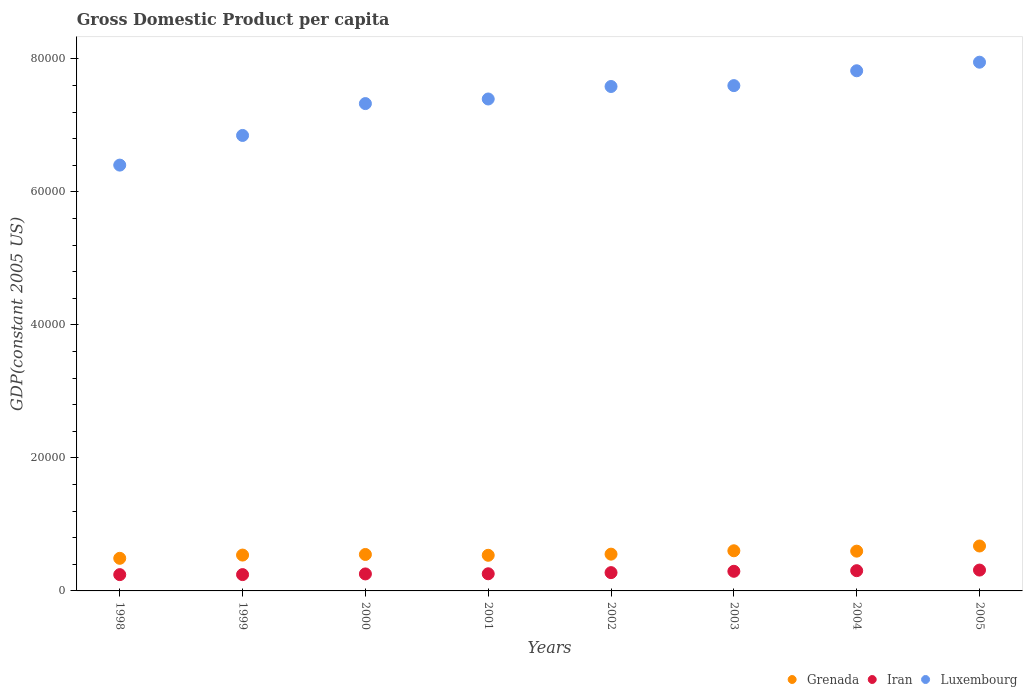Is the number of dotlines equal to the number of legend labels?
Your response must be concise. Yes. What is the GDP per capita in Iran in 2002?
Your response must be concise. 2749.31. Across all years, what is the maximum GDP per capita in Iran?
Offer a very short reply. 3135.19. Across all years, what is the minimum GDP per capita in Luxembourg?
Ensure brevity in your answer.  6.40e+04. In which year was the GDP per capita in Luxembourg maximum?
Offer a very short reply. 2005. What is the total GDP per capita in Luxembourg in the graph?
Keep it short and to the point. 5.89e+05. What is the difference between the GDP per capita in Iran in 2000 and that in 2005?
Offer a terse response. -581.15. What is the difference between the GDP per capita in Grenada in 1998 and the GDP per capita in Iran in 2000?
Make the answer very short. 2349.24. What is the average GDP per capita in Grenada per year?
Give a very brief answer. 5678.86. In the year 2004, what is the difference between the GDP per capita in Luxembourg and GDP per capita in Iran?
Offer a terse response. 7.52e+04. What is the ratio of the GDP per capita in Grenada in 1999 to that in 2003?
Make the answer very short. 0.89. Is the difference between the GDP per capita in Luxembourg in 1999 and 2003 greater than the difference between the GDP per capita in Iran in 1999 and 2003?
Provide a succinct answer. No. What is the difference between the highest and the second highest GDP per capita in Luxembourg?
Offer a very short reply. 1289.74. What is the difference between the highest and the lowest GDP per capita in Grenada?
Provide a succinct answer. 1851.11. In how many years, is the GDP per capita in Grenada greater than the average GDP per capita in Grenada taken over all years?
Provide a succinct answer. 3. Is it the case that in every year, the sum of the GDP per capita in Luxembourg and GDP per capita in Grenada  is greater than the GDP per capita in Iran?
Provide a short and direct response. Yes. Does the GDP per capita in Grenada monotonically increase over the years?
Your answer should be very brief. No. Is the GDP per capita in Grenada strictly less than the GDP per capita in Luxembourg over the years?
Your answer should be very brief. Yes. How many dotlines are there?
Give a very brief answer. 3. How many years are there in the graph?
Your answer should be compact. 8. Does the graph contain any zero values?
Give a very brief answer. No. Does the graph contain grids?
Offer a very short reply. No. How many legend labels are there?
Offer a terse response. 3. What is the title of the graph?
Offer a terse response. Gross Domestic Product per capita. Does "Cyprus" appear as one of the legend labels in the graph?
Keep it short and to the point. No. What is the label or title of the X-axis?
Offer a very short reply. Years. What is the label or title of the Y-axis?
Your response must be concise. GDP(constant 2005 US). What is the GDP(constant 2005 US) in Grenada in 1998?
Offer a terse response. 4903.28. What is the GDP(constant 2005 US) in Iran in 1998?
Your answer should be compact. 2448.68. What is the GDP(constant 2005 US) of Luxembourg in 1998?
Ensure brevity in your answer.  6.40e+04. What is the GDP(constant 2005 US) in Grenada in 1999?
Provide a short and direct response. 5389.76. What is the GDP(constant 2005 US) of Iran in 1999?
Give a very brief answer. 2452.83. What is the GDP(constant 2005 US) in Luxembourg in 1999?
Keep it short and to the point. 6.85e+04. What is the GDP(constant 2005 US) of Grenada in 2000?
Ensure brevity in your answer.  5481.04. What is the GDP(constant 2005 US) of Iran in 2000?
Ensure brevity in your answer.  2554.04. What is the GDP(constant 2005 US) of Luxembourg in 2000?
Keep it short and to the point. 7.33e+04. What is the GDP(constant 2005 US) of Grenada in 2001?
Provide a short and direct response. 5358.03. What is the GDP(constant 2005 US) of Iran in 2001?
Provide a short and direct response. 2577.45. What is the GDP(constant 2005 US) in Luxembourg in 2001?
Your answer should be very brief. 7.40e+04. What is the GDP(constant 2005 US) in Grenada in 2002?
Give a very brief answer. 5528.58. What is the GDP(constant 2005 US) of Iran in 2002?
Ensure brevity in your answer.  2749.31. What is the GDP(constant 2005 US) in Luxembourg in 2002?
Your answer should be compact. 7.58e+04. What is the GDP(constant 2005 US) in Grenada in 2003?
Your answer should be compact. 6035.78. What is the GDP(constant 2005 US) of Iran in 2003?
Make the answer very short. 2950.85. What is the GDP(constant 2005 US) in Luxembourg in 2003?
Your answer should be very brief. 7.60e+04. What is the GDP(constant 2005 US) of Grenada in 2004?
Offer a very short reply. 5980. What is the GDP(constant 2005 US) of Iran in 2004?
Your response must be concise. 3043.29. What is the GDP(constant 2005 US) in Luxembourg in 2004?
Ensure brevity in your answer.  7.82e+04. What is the GDP(constant 2005 US) of Grenada in 2005?
Provide a short and direct response. 6754.38. What is the GDP(constant 2005 US) in Iran in 2005?
Ensure brevity in your answer.  3135.19. What is the GDP(constant 2005 US) of Luxembourg in 2005?
Ensure brevity in your answer.  7.95e+04. Across all years, what is the maximum GDP(constant 2005 US) in Grenada?
Your response must be concise. 6754.38. Across all years, what is the maximum GDP(constant 2005 US) in Iran?
Your answer should be very brief. 3135.19. Across all years, what is the maximum GDP(constant 2005 US) in Luxembourg?
Provide a short and direct response. 7.95e+04. Across all years, what is the minimum GDP(constant 2005 US) in Grenada?
Ensure brevity in your answer.  4903.28. Across all years, what is the minimum GDP(constant 2005 US) in Iran?
Your response must be concise. 2448.68. Across all years, what is the minimum GDP(constant 2005 US) of Luxembourg?
Keep it short and to the point. 6.40e+04. What is the total GDP(constant 2005 US) of Grenada in the graph?
Offer a very short reply. 4.54e+04. What is the total GDP(constant 2005 US) in Iran in the graph?
Give a very brief answer. 2.19e+04. What is the total GDP(constant 2005 US) in Luxembourg in the graph?
Ensure brevity in your answer.  5.89e+05. What is the difference between the GDP(constant 2005 US) in Grenada in 1998 and that in 1999?
Offer a very short reply. -486.49. What is the difference between the GDP(constant 2005 US) in Iran in 1998 and that in 1999?
Provide a short and direct response. -4.15. What is the difference between the GDP(constant 2005 US) in Luxembourg in 1998 and that in 1999?
Your answer should be very brief. -4459.64. What is the difference between the GDP(constant 2005 US) in Grenada in 1998 and that in 2000?
Ensure brevity in your answer.  -577.76. What is the difference between the GDP(constant 2005 US) of Iran in 1998 and that in 2000?
Give a very brief answer. -105.35. What is the difference between the GDP(constant 2005 US) in Luxembourg in 1998 and that in 2000?
Your response must be concise. -9249.24. What is the difference between the GDP(constant 2005 US) in Grenada in 1998 and that in 2001?
Give a very brief answer. -454.76. What is the difference between the GDP(constant 2005 US) in Iran in 1998 and that in 2001?
Your response must be concise. -128.77. What is the difference between the GDP(constant 2005 US) in Luxembourg in 1998 and that in 2001?
Keep it short and to the point. -9940.9. What is the difference between the GDP(constant 2005 US) of Grenada in 1998 and that in 2002?
Give a very brief answer. -625.3. What is the difference between the GDP(constant 2005 US) of Iran in 1998 and that in 2002?
Provide a short and direct response. -300.63. What is the difference between the GDP(constant 2005 US) in Luxembourg in 1998 and that in 2002?
Keep it short and to the point. -1.18e+04. What is the difference between the GDP(constant 2005 US) of Grenada in 1998 and that in 2003?
Your answer should be compact. -1132.51. What is the difference between the GDP(constant 2005 US) in Iran in 1998 and that in 2003?
Ensure brevity in your answer.  -502.17. What is the difference between the GDP(constant 2005 US) of Luxembourg in 1998 and that in 2003?
Offer a terse response. -1.20e+04. What is the difference between the GDP(constant 2005 US) in Grenada in 1998 and that in 2004?
Keep it short and to the point. -1076.72. What is the difference between the GDP(constant 2005 US) of Iran in 1998 and that in 2004?
Provide a short and direct response. -594.61. What is the difference between the GDP(constant 2005 US) in Luxembourg in 1998 and that in 2004?
Offer a very short reply. -1.42e+04. What is the difference between the GDP(constant 2005 US) of Grenada in 1998 and that in 2005?
Your answer should be compact. -1851.11. What is the difference between the GDP(constant 2005 US) in Iran in 1998 and that in 2005?
Provide a succinct answer. -686.51. What is the difference between the GDP(constant 2005 US) of Luxembourg in 1998 and that in 2005?
Provide a succinct answer. -1.55e+04. What is the difference between the GDP(constant 2005 US) of Grenada in 1999 and that in 2000?
Offer a very short reply. -91.27. What is the difference between the GDP(constant 2005 US) of Iran in 1999 and that in 2000?
Your answer should be very brief. -101.21. What is the difference between the GDP(constant 2005 US) of Luxembourg in 1999 and that in 2000?
Make the answer very short. -4789.6. What is the difference between the GDP(constant 2005 US) of Grenada in 1999 and that in 2001?
Give a very brief answer. 31.73. What is the difference between the GDP(constant 2005 US) in Iran in 1999 and that in 2001?
Give a very brief answer. -124.62. What is the difference between the GDP(constant 2005 US) in Luxembourg in 1999 and that in 2001?
Offer a terse response. -5481.26. What is the difference between the GDP(constant 2005 US) of Grenada in 1999 and that in 2002?
Give a very brief answer. -138.82. What is the difference between the GDP(constant 2005 US) in Iran in 1999 and that in 2002?
Provide a short and direct response. -296.48. What is the difference between the GDP(constant 2005 US) in Luxembourg in 1999 and that in 2002?
Keep it short and to the point. -7360.54. What is the difference between the GDP(constant 2005 US) in Grenada in 1999 and that in 2003?
Give a very brief answer. -646.02. What is the difference between the GDP(constant 2005 US) of Iran in 1999 and that in 2003?
Your answer should be very brief. -498.02. What is the difference between the GDP(constant 2005 US) of Luxembourg in 1999 and that in 2003?
Keep it short and to the point. -7491.68. What is the difference between the GDP(constant 2005 US) in Grenada in 1999 and that in 2004?
Your answer should be compact. -590.23. What is the difference between the GDP(constant 2005 US) in Iran in 1999 and that in 2004?
Provide a succinct answer. -590.46. What is the difference between the GDP(constant 2005 US) in Luxembourg in 1999 and that in 2004?
Make the answer very short. -9723.44. What is the difference between the GDP(constant 2005 US) of Grenada in 1999 and that in 2005?
Provide a succinct answer. -1364.62. What is the difference between the GDP(constant 2005 US) in Iran in 1999 and that in 2005?
Offer a very short reply. -682.36. What is the difference between the GDP(constant 2005 US) of Luxembourg in 1999 and that in 2005?
Ensure brevity in your answer.  -1.10e+04. What is the difference between the GDP(constant 2005 US) in Grenada in 2000 and that in 2001?
Make the answer very short. 123. What is the difference between the GDP(constant 2005 US) in Iran in 2000 and that in 2001?
Offer a very short reply. -23.42. What is the difference between the GDP(constant 2005 US) of Luxembourg in 2000 and that in 2001?
Ensure brevity in your answer.  -691.66. What is the difference between the GDP(constant 2005 US) in Grenada in 2000 and that in 2002?
Your answer should be very brief. -47.54. What is the difference between the GDP(constant 2005 US) in Iran in 2000 and that in 2002?
Your answer should be very brief. -195.27. What is the difference between the GDP(constant 2005 US) of Luxembourg in 2000 and that in 2002?
Provide a short and direct response. -2570.93. What is the difference between the GDP(constant 2005 US) of Grenada in 2000 and that in 2003?
Offer a very short reply. -554.75. What is the difference between the GDP(constant 2005 US) in Iran in 2000 and that in 2003?
Provide a succinct answer. -396.81. What is the difference between the GDP(constant 2005 US) in Luxembourg in 2000 and that in 2003?
Your response must be concise. -2702.08. What is the difference between the GDP(constant 2005 US) of Grenada in 2000 and that in 2004?
Ensure brevity in your answer.  -498.96. What is the difference between the GDP(constant 2005 US) in Iran in 2000 and that in 2004?
Keep it short and to the point. -489.26. What is the difference between the GDP(constant 2005 US) in Luxembourg in 2000 and that in 2004?
Offer a very short reply. -4933.84. What is the difference between the GDP(constant 2005 US) of Grenada in 2000 and that in 2005?
Provide a short and direct response. -1273.35. What is the difference between the GDP(constant 2005 US) in Iran in 2000 and that in 2005?
Ensure brevity in your answer.  -581.15. What is the difference between the GDP(constant 2005 US) of Luxembourg in 2000 and that in 2005?
Your answer should be compact. -6223.57. What is the difference between the GDP(constant 2005 US) of Grenada in 2001 and that in 2002?
Offer a very short reply. -170.55. What is the difference between the GDP(constant 2005 US) of Iran in 2001 and that in 2002?
Your answer should be compact. -171.85. What is the difference between the GDP(constant 2005 US) of Luxembourg in 2001 and that in 2002?
Your answer should be compact. -1879.27. What is the difference between the GDP(constant 2005 US) of Grenada in 2001 and that in 2003?
Your answer should be very brief. -677.75. What is the difference between the GDP(constant 2005 US) of Iran in 2001 and that in 2003?
Make the answer very short. -373.4. What is the difference between the GDP(constant 2005 US) of Luxembourg in 2001 and that in 2003?
Offer a terse response. -2010.42. What is the difference between the GDP(constant 2005 US) of Grenada in 2001 and that in 2004?
Your answer should be compact. -621.97. What is the difference between the GDP(constant 2005 US) in Iran in 2001 and that in 2004?
Offer a very short reply. -465.84. What is the difference between the GDP(constant 2005 US) of Luxembourg in 2001 and that in 2004?
Offer a very short reply. -4242.18. What is the difference between the GDP(constant 2005 US) of Grenada in 2001 and that in 2005?
Provide a short and direct response. -1396.35. What is the difference between the GDP(constant 2005 US) in Iran in 2001 and that in 2005?
Offer a terse response. -557.73. What is the difference between the GDP(constant 2005 US) in Luxembourg in 2001 and that in 2005?
Your answer should be very brief. -5531.91. What is the difference between the GDP(constant 2005 US) of Grenada in 2002 and that in 2003?
Offer a terse response. -507.2. What is the difference between the GDP(constant 2005 US) of Iran in 2002 and that in 2003?
Offer a very short reply. -201.54. What is the difference between the GDP(constant 2005 US) in Luxembourg in 2002 and that in 2003?
Keep it short and to the point. -131.14. What is the difference between the GDP(constant 2005 US) in Grenada in 2002 and that in 2004?
Your response must be concise. -451.42. What is the difference between the GDP(constant 2005 US) of Iran in 2002 and that in 2004?
Offer a very short reply. -293.99. What is the difference between the GDP(constant 2005 US) of Luxembourg in 2002 and that in 2004?
Provide a short and direct response. -2362.9. What is the difference between the GDP(constant 2005 US) in Grenada in 2002 and that in 2005?
Your response must be concise. -1225.8. What is the difference between the GDP(constant 2005 US) of Iran in 2002 and that in 2005?
Keep it short and to the point. -385.88. What is the difference between the GDP(constant 2005 US) of Luxembourg in 2002 and that in 2005?
Provide a short and direct response. -3652.64. What is the difference between the GDP(constant 2005 US) of Grenada in 2003 and that in 2004?
Provide a short and direct response. 55.79. What is the difference between the GDP(constant 2005 US) of Iran in 2003 and that in 2004?
Provide a succinct answer. -92.44. What is the difference between the GDP(constant 2005 US) of Luxembourg in 2003 and that in 2004?
Your response must be concise. -2231.76. What is the difference between the GDP(constant 2005 US) in Grenada in 2003 and that in 2005?
Make the answer very short. -718.6. What is the difference between the GDP(constant 2005 US) in Iran in 2003 and that in 2005?
Your answer should be very brief. -184.34. What is the difference between the GDP(constant 2005 US) of Luxembourg in 2003 and that in 2005?
Your answer should be compact. -3521.5. What is the difference between the GDP(constant 2005 US) of Grenada in 2004 and that in 2005?
Your response must be concise. -774.38. What is the difference between the GDP(constant 2005 US) of Iran in 2004 and that in 2005?
Your response must be concise. -91.89. What is the difference between the GDP(constant 2005 US) of Luxembourg in 2004 and that in 2005?
Offer a very short reply. -1289.74. What is the difference between the GDP(constant 2005 US) in Grenada in 1998 and the GDP(constant 2005 US) in Iran in 1999?
Your answer should be compact. 2450.45. What is the difference between the GDP(constant 2005 US) of Grenada in 1998 and the GDP(constant 2005 US) of Luxembourg in 1999?
Make the answer very short. -6.36e+04. What is the difference between the GDP(constant 2005 US) in Iran in 1998 and the GDP(constant 2005 US) in Luxembourg in 1999?
Provide a short and direct response. -6.60e+04. What is the difference between the GDP(constant 2005 US) in Grenada in 1998 and the GDP(constant 2005 US) in Iran in 2000?
Provide a short and direct response. 2349.24. What is the difference between the GDP(constant 2005 US) of Grenada in 1998 and the GDP(constant 2005 US) of Luxembourg in 2000?
Your response must be concise. -6.84e+04. What is the difference between the GDP(constant 2005 US) in Iran in 1998 and the GDP(constant 2005 US) in Luxembourg in 2000?
Give a very brief answer. -7.08e+04. What is the difference between the GDP(constant 2005 US) in Grenada in 1998 and the GDP(constant 2005 US) in Iran in 2001?
Your response must be concise. 2325.82. What is the difference between the GDP(constant 2005 US) of Grenada in 1998 and the GDP(constant 2005 US) of Luxembourg in 2001?
Offer a terse response. -6.91e+04. What is the difference between the GDP(constant 2005 US) of Iran in 1998 and the GDP(constant 2005 US) of Luxembourg in 2001?
Offer a terse response. -7.15e+04. What is the difference between the GDP(constant 2005 US) in Grenada in 1998 and the GDP(constant 2005 US) in Iran in 2002?
Your response must be concise. 2153.97. What is the difference between the GDP(constant 2005 US) in Grenada in 1998 and the GDP(constant 2005 US) in Luxembourg in 2002?
Offer a very short reply. -7.09e+04. What is the difference between the GDP(constant 2005 US) in Iran in 1998 and the GDP(constant 2005 US) in Luxembourg in 2002?
Give a very brief answer. -7.34e+04. What is the difference between the GDP(constant 2005 US) of Grenada in 1998 and the GDP(constant 2005 US) of Iran in 2003?
Your answer should be compact. 1952.43. What is the difference between the GDP(constant 2005 US) in Grenada in 1998 and the GDP(constant 2005 US) in Luxembourg in 2003?
Your response must be concise. -7.11e+04. What is the difference between the GDP(constant 2005 US) of Iran in 1998 and the GDP(constant 2005 US) of Luxembourg in 2003?
Provide a succinct answer. -7.35e+04. What is the difference between the GDP(constant 2005 US) of Grenada in 1998 and the GDP(constant 2005 US) of Iran in 2004?
Offer a terse response. 1859.98. What is the difference between the GDP(constant 2005 US) in Grenada in 1998 and the GDP(constant 2005 US) in Luxembourg in 2004?
Give a very brief answer. -7.33e+04. What is the difference between the GDP(constant 2005 US) of Iran in 1998 and the GDP(constant 2005 US) of Luxembourg in 2004?
Ensure brevity in your answer.  -7.58e+04. What is the difference between the GDP(constant 2005 US) of Grenada in 1998 and the GDP(constant 2005 US) of Iran in 2005?
Provide a short and direct response. 1768.09. What is the difference between the GDP(constant 2005 US) in Grenada in 1998 and the GDP(constant 2005 US) in Luxembourg in 2005?
Provide a succinct answer. -7.46e+04. What is the difference between the GDP(constant 2005 US) in Iran in 1998 and the GDP(constant 2005 US) in Luxembourg in 2005?
Provide a short and direct response. -7.70e+04. What is the difference between the GDP(constant 2005 US) of Grenada in 1999 and the GDP(constant 2005 US) of Iran in 2000?
Ensure brevity in your answer.  2835.73. What is the difference between the GDP(constant 2005 US) of Grenada in 1999 and the GDP(constant 2005 US) of Luxembourg in 2000?
Keep it short and to the point. -6.79e+04. What is the difference between the GDP(constant 2005 US) of Iran in 1999 and the GDP(constant 2005 US) of Luxembourg in 2000?
Your answer should be very brief. -7.08e+04. What is the difference between the GDP(constant 2005 US) of Grenada in 1999 and the GDP(constant 2005 US) of Iran in 2001?
Keep it short and to the point. 2812.31. What is the difference between the GDP(constant 2005 US) in Grenada in 1999 and the GDP(constant 2005 US) in Luxembourg in 2001?
Provide a succinct answer. -6.86e+04. What is the difference between the GDP(constant 2005 US) of Iran in 1999 and the GDP(constant 2005 US) of Luxembourg in 2001?
Provide a succinct answer. -7.15e+04. What is the difference between the GDP(constant 2005 US) in Grenada in 1999 and the GDP(constant 2005 US) in Iran in 2002?
Provide a short and direct response. 2640.46. What is the difference between the GDP(constant 2005 US) of Grenada in 1999 and the GDP(constant 2005 US) of Luxembourg in 2002?
Your answer should be compact. -7.05e+04. What is the difference between the GDP(constant 2005 US) in Iran in 1999 and the GDP(constant 2005 US) in Luxembourg in 2002?
Provide a short and direct response. -7.34e+04. What is the difference between the GDP(constant 2005 US) of Grenada in 1999 and the GDP(constant 2005 US) of Iran in 2003?
Ensure brevity in your answer.  2438.91. What is the difference between the GDP(constant 2005 US) of Grenada in 1999 and the GDP(constant 2005 US) of Luxembourg in 2003?
Provide a short and direct response. -7.06e+04. What is the difference between the GDP(constant 2005 US) in Iran in 1999 and the GDP(constant 2005 US) in Luxembourg in 2003?
Make the answer very short. -7.35e+04. What is the difference between the GDP(constant 2005 US) in Grenada in 1999 and the GDP(constant 2005 US) in Iran in 2004?
Your answer should be very brief. 2346.47. What is the difference between the GDP(constant 2005 US) in Grenada in 1999 and the GDP(constant 2005 US) in Luxembourg in 2004?
Make the answer very short. -7.28e+04. What is the difference between the GDP(constant 2005 US) in Iran in 1999 and the GDP(constant 2005 US) in Luxembourg in 2004?
Offer a very short reply. -7.58e+04. What is the difference between the GDP(constant 2005 US) in Grenada in 1999 and the GDP(constant 2005 US) in Iran in 2005?
Make the answer very short. 2254.58. What is the difference between the GDP(constant 2005 US) in Grenada in 1999 and the GDP(constant 2005 US) in Luxembourg in 2005?
Offer a very short reply. -7.41e+04. What is the difference between the GDP(constant 2005 US) of Iran in 1999 and the GDP(constant 2005 US) of Luxembourg in 2005?
Give a very brief answer. -7.70e+04. What is the difference between the GDP(constant 2005 US) of Grenada in 2000 and the GDP(constant 2005 US) of Iran in 2001?
Provide a short and direct response. 2903.58. What is the difference between the GDP(constant 2005 US) in Grenada in 2000 and the GDP(constant 2005 US) in Luxembourg in 2001?
Provide a succinct answer. -6.85e+04. What is the difference between the GDP(constant 2005 US) in Iran in 2000 and the GDP(constant 2005 US) in Luxembourg in 2001?
Keep it short and to the point. -7.14e+04. What is the difference between the GDP(constant 2005 US) of Grenada in 2000 and the GDP(constant 2005 US) of Iran in 2002?
Offer a very short reply. 2731.73. What is the difference between the GDP(constant 2005 US) of Grenada in 2000 and the GDP(constant 2005 US) of Luxembourg in 2002?
Give a very brief answer. -7.04e+04. What is the difference between the GDP(constant 2005 US) of Iran in 2000 and the GDP(constant 2005 US) of Luxembourg in 2002?
Offer a very short reply. -7.33e+04. What is the difference between the GDP(constant 2005 US) in Grenada in 2000 and the GDP(constant 2005 US) in Iran in 2003?
Your answer should be compact. 2530.19. What is the difference between the GDP(constant 2005 US) of Grenada in 2000 and the GDP(constant 2005 US) of Luxembourg in 2003?
Offer a terse response. -7.05e+04. What is the difference between the GDP(constant 2005 US) of Iran in 2000 and the GDP(constant 2005 US) of Luxembourg in 2003?
Your response must be concise. -7.34e+04. What is the difference between the GDP(constant 2005 US) of Grenada in 2000 and the GDP(constant 2005 US) of Iran in 2004?
Your answer should be compact. 2437.74. What is the difference between the GDP(constant 2005 US) in Grenada in 2000 and the GDP(constant 2005 US) in Luxembourg in 2004?
Keep it short and to the point. -7.27e+04. What is the difference between the GDP(constant 2005 US) of Iran in 2000 and the GDP(constant 2005 US) of Luxembourg in 2004?
Keep it short and to the point. -7.57e+04. What is the difference between the GDP(constant 2005 US) in Grenada in 2000 and the GDP(constant 2005 US) in Iran in 2005?
Offer a very short reply. 2345.85. What is the difference between the GDP(constant 2005 US) in Grenada in 2000 and the GDP(constant 2005 US) in Luxembourg in 2005?
Provide a succinct answer. -7.40e+04. What is the difference between the GDP(constant 2005 US) in Iran in 2000 and the GDP(constant 2005 US) in Luxembourg in 2005?
Your answer should be compact. -7.69e+04. What is the difference between the GDP(constant 2005 US) in Grenada in 2001 and the GDP(constant 2005 US) in Iran in 2002?
Give a very brief answer. 2608.72. What is the difference between the GDP(constant 2005 US) in Grenada in 2001 and the GDP(constant 2005 US) in Luxembourg in 2002?
Offer a terse response. -7.05e+04. What is the difference between the GDP(constant 2005 US) in Iran in 2001 and the GDP(constant 2005 US) in Luxembourg in 2002?
Ensure brevity in your answer.  -7.33e+04. What is the difference between the GDP(constant 2005 US) in Grenada in 2001 and the GDP(constant 2005 US) in Iran in 2003?
Ensure brevity in your answer.  2407.18. What is the difference between the GDP(constant 2005 US) in Grenada in 2001 and the GDP(constant 2005 US) in Luxembourg in 2003?
Ensure brevity in your answer.  -7.06e+04. What is the difference between the GDP(constant 2005 US) in Iran in 2001 and the GDP(constant 2005 US) in Luxembourg in 2003?
Your answer should be compact. -7.34e+04. What is the difference between the GDP(constant 2005 US) in Grenada in 2001 and the GDP(constant 2005 US) in Iran in 2004?
Ensure brevity in your answer.  2314.74. What is the difference between the GDP(constant 2005 US) in Grenada in 2001 and the GDP(constant 2005 US) in Luxembourg in 2004?
Give a very brief answer. -7.28e+04. What is the difference between the GDP(constant 2005 US) in Iran in 2001 and the GDP(constant 2005 US) in Luxembourg in 2004?
Ensure brevity in your answer.  -7.56e+04. What is the difference between the GDP(constant 2005 US) of Grenada in 2001 and the GDP(constant 2005 US) of Iran in 2005?
Ensure brevity in your answer.  2222.84. What is the difference between the GDP(constant 2005 US) of Grenada in 2001 and the GDP(constant 2005 US) of Luxembourg in 2005?
Offer a very short reply. -7.41e+04. What is the difference between the GDP(constant 2005 US) of Iran in 2001 and the GDP(constant 2005 US) of Luxembourg in 2005?
Provide a succinct answer. -7.69e+04. What is the difference between the GDP(constant 2005 US) in Grenada in 2002 and the GDP(constant 2005 US) in Iran in 2003?
Your answer should be compact. 2577.73. What is the difference between the GDP(constant 2005 US) of Grenada in 2002 and the GDP(constant 2005 US) of Luxembourg in 2003?
Give a very brief answer. -7.04e+04. What is the difference between the GDP(constant 2005 US) in Iran in 2002 and the GDP(constant 2005 US) in Luxembourg in 2003?
Keep it short and to the point. -7.32e+04. What is the difference between the GDP(constant 2005 US) of Grenada in 2002 and the GDP(constant 2005 US) of Iran in 2004?
Provide a succinct answer. 2485.29. What is the difference between the GDP(constant 2005 US) in Grenada in 2002 and the GDP(constant 2005 US) in Luxembourg in 2004?
Ensure brevity in your answer.  -7.27e+04. What is the difference between the GDP(constant 2005 US) of Iran in 2002 and the GDP(constant 2005 US) of Luxembourg in 2004?
Provide a succinct answer. -7.55e+04. What is the difference between the GDP(constant 2005 US) of Grenada in 2002 and the GDP(constant 2005 US) of Iran in 2005?
Your response must be concise. 2393.39. What is the difference between the GDP(constant 2005 US) of Grenada in 2002 and the GDP(constant 2005 US) of Luxembourg in 2005?
Ensure brevity in your answer.  -7.40e+04. What is the difference between the GDP(constant 2005 US) in Iran in 2002 and the GDP(constant 2005 US) in Luxembourg in 2005?
Keep it short and to the point. -7.67e+04. What is the difference between the GDP(constant 2005 US) of Grenada in 2003 and the GDP(constant 2005 US) of Iran in 2004?
Give a very brief answer. 2992.49. What is the difference between the GDP(constant 2005 US) in Grenada in 2003 and the GDP(constant 2005 US) in Luxembourg in 2004?
Provide a short and direct response. -7.22e+04. What is the difference between the GDP(constant 2005 US) of Iran in 2003 and the GDP(constant 2005 US) of Luxembourg in 2004?
Your response must be concise. -7.53e+04. What is the difference between the GDP(constant 2005 US) in Grenada in 2003 and the GDP(constant 2005 US) in Iran in 2005?
Your response must be concise. 2900.59. What is the difference between the GDP(constant 2005 US) in Grenada in 2003 and the GDP(constant 2005 US) in Luxembourg in 2005?
Provide a short and direct response. -7.35e+04. What is the difference between the GDP(constant 2005 US) in Iran in 2003 and the GDP(constant 2005 US) in Luxembourg in 2005?
Offer a very short reply. -7.65e+04. What is the difference between the GDP(constant 2005 US) of Grenada in 2004 and the GDP(constant 2005 US) of Iran in 2005?
Provide a succinct answer. 2844.81. What is the difference between the GDP(constant 2005 US) in Grenada in 2004 and the GDP(constant 2005 US) in Luxembourg in 2005?
Make the answer very short. -7.35e+04. What is the difference between the GDP(constant 2005 US) in Iran in 2004 and the GDP(constant 2005 US) in Luxembourg in 2005?
Make the answer very short. -7.65e+04. What is the average GDP(constant 2005 US) of Grenada per year?
Give a very brief answer. 5678.86. What is the average GDP(constant 2005 US) of Iran per year?
Your response must be concise. 2738.95. What is the average GDP(constant 2005 US) in Luxembourg per year?
Offer a terse response. 7.37e+04. In the year 1998, what is the difference between the GDP(constant 2005 US) of Grenada and GDP(constant 2005 US) of Iran?
Ensure brevity in your answer.  2454.59. In the year 1998, what is the difference between the GDP(constant 2005 US) in Grenada and GDP(constant 2005 US) in Luxembourg?
Your response must be concise. -5.91e+04. In the year 1998, what is the difference between the GDP(constant 2005 US) of Iran and GDP(constant 2005 US) of Luxembourg?
Offer a very short reply. -6.16e+04. In the year 1999, what is the difference between the GDP(constant 2005 US) in Grenada and GDP(constant 2005 US) in Iran?
Provide a succinct answer. 2936.93. In the year 1999, what is the difference between the GDP(constant 2005 US) in Grenada and GDP(constant 2005 US) in Luxembourg?
Make the answer very short. -6.31e+04. In the year 1999, what is the difference between the GDP(constant 2005 US) in Iran and GDP(constant 2005 US) in Luxembourg?
Your answer should be compact. -6.60e+04. In the year 2000, what is the difference between the GDP(constant 2005 US) in Grenada and GDP(constant 2005 US) in Iran?
Provide a succinct answer. 2927. In the year 2000, what is the difference between the GDP(constant 2005 US) in Grenada and GDP(constant 2005 US) in Luxembourg?
Offer a very short reply. -6.78e+04. In the year 2000, what is the difference between the GDP(constant 2005 US) of Iran and GDP(constant 2005 US) of Luxembourg?
Ensure brevity in your answer.  -7.07e+04. In the year 2001, what is the difference between the GDP(constant 2005 US) of Grenada and GDP(constant 2005 US) of Iran?
Offer a very short reply. 2780.58. In the year 2001, what is the difference between the GDP(constant 2005 US) in Grenada and GDP(constant 2005 US) in Luxembourg?
Provide a short and direct response. -6.86e+04. In the year 2001, what is the difference between the GDP(constant 2005 US) in Iran and GDP(constant 2005 US) in Luxembourg?
Provide a short and direct response. -7.14e+04. In the year 2002, what is the difference between the GDP(constant 2005 US) in Grenada and GDP(constant 2005 US) in Iran?
Give a very brief answer. 2779.27. In the year 2002, what is the difference between the GDP(constant 2005 US) of Grenada and GDP(constant 2005 US) of Luxembourg?
Provide a succinct answer. -7.03e+04. In the year 2002, what is the difference between the GDP(constant 2005 US) in Iran and GDP(constant 2005 US) in Luxembourg?
Provide a succinct answer. -7.31e+04. In the year 2003, what is the difference between the GDP(constant 2005 US) in Grenada and GDP(constant 2005 US) in Iran?
Keep it short and to the point. 3084.93. In the year 2003, what is the difference between the GDP(constant 2005 US) in Grenada and GDP(constant 2005 US) in Luxembourg?
Ensure brevity in your answer.  -6.99e+04. In the year 2003, what is the difference between the GDP(constant 2005 US) in Iran and GDP(constant 2005 US) in Luxembourg?
Your answer should be compact. -7.30e+04. In the year 2004, what is the difference between the GDP(constant 2005 US) in Grenada and GDP(constant 2005 US) in Iran?
Offer a terse response. 2936.7. In the year 2004, what is the difference between the GDP(constant 2005 US) of Grenada and GDP(constant 2005 US) of Luxembourg?
Ensure brevity in your answer.  -7.22e+04. In the year 2004, what is the difference between the GDP(constant 2005 US) of Iran and GDP(constant 2005 US) of Luxembourg?
Offer a terse response. -7.52e+04. In the year 2005, what is the difference between the GDP(constant 2005 US) of Grenada and GDP(constant 2005 US) of Iran?
Provide a succinct answer. 3619.19. In the year 2005, what is the difference between the GDP(constant 2005 US) in Grenada and GDP(constant 2005 US) in Luxembourg?
Provide a short and direct response. -7.27e+04. In the year 2005, what is the difference between the GDP(constant 2005 US) in Iran and GDP(constant 2005 US) in Luxembourg?
Your response must be concise. -7.64e+04. What is the ratio of the GDP(constant 2005 US) of Grenada in 1998 to that in 1999?
Offer a terse response. 0.91. What is the ratio of the GDP(constant 2005 US) of Iran in 1998 to that in 1999?
Your response must be concise. 1. What is the ratio of the GDP(constant 2005 US) of Luxembourg in 1998 to that in 1999?
Provide a succinct answer. 0.93. What is the ratio of the GDP(constant 2005 US) in Grenada in 1998 to that in 2000?
Keep it short and to the point. 0.89. What is the ratio of the GDP(constant 2005 US) in Iran in 1998 to that in 2000?
Keep it short and to the point. 0.96. What is the ratio of the GDP(constant 2005 US) of Luxembourg in 1998 to that in 2000?
Give a very brief answer. 0.87. What is the ratio of the GDP(constant 2005 US) of Grenada in 1998 to that in 2001?
Provide a succinct answer. 0.92. What is the ratio of the GDP(constant 2005 US) of Iran in 1998 to that in 2001?
Make the answer very short. 0.95. What is the ratio of the GDP(constant 2005 US) of Luxembourg in 1998 to that in 2001?
Provide a short and direct response. 0.87. What is the ratio of the GDP(constant 2005 US) of Grenada in 1998 to that in 2002?
Provide a succinct answer. 0.89. What is the ratio of the GDP(constant 2005 US) in Iran in 1998 to that in 2002?
Keep it short and to the point. 0.89. What is the ratio of the GDP(constant 2005 US) in Luxembourg in 1998 to that in 2002?
Your answer should be compact. 0.84. What is the ratio of the GDP(constant 2005 US) of Grenada in 1998 to that in 2003?
Your answer should be very brief. 0.81. What is the ratio of the GDP(constant 2005 US) in Iran in 1998 to that in 2003?
Give a very brief answer. 0.83. What is the ratio of the GDP(constant 2005 US) in Luxembourg in 1998 to that in 2003?
Offer a very short reply. 0.84. What is the ratio of the GDP(constant 2005 US) of Grenada in 1998 to that in 2004?
Make the answer very short. 0.82. What is the ratio of the GDP(constant 2005 US) in Iran in 1998 to that in 2004?
Provide a short and direct response. 0.8. What is the ratio of the GDP(constant 2005 US) in Luxembourg in 1998 to that in 2004?
Offer a very short reply. 0.82. What is the ratio of the GDP(constant 2005 US) of Grenada in 1998 to that in 2005?
Ensure brevity in your answer.  0.73. What is the ratio of the GDP(constant 2005 US) of Iran in 1998 to that in 2005?
Ensure brevity in your answer.  0.78. What is the ratio of the GDP(constant 2005 US) of Luxembourg in 1998 to that in 2005?
Your answer should be compact. 0.81. What is the ratio of the GDP(constant 2005 US) in Grenada in 1999 to that in 2000?
Your response must be concise. 0.98. What is the ratio of the GDP(constant 2005 US) in Iran in 1999 to that in 2000?
Provide a short and direct response. 0.96. What is the ratio of the GDP(constant 2005 US) of Luxembourg in 1999 to that in 2000?
Provide a short and direct response. 0.93. What is the ratio of the GDP(constant 2005 US) of Grenada in 1999 to that in 2001?
Your answer should be very brief. 1.01. What is the ratio of the GDP(constant 2005 US) of Iran in 1999 to that in 2001?
Ensure brevity in your answer.  0.95. What is the ratio of the GDP(constant 2005 US) in Luxembourg in 1999 to that in 2001?
Your response must be concise. 0.93. What is the ratio of the GDP(constant 2005 US) in Grenada in 1999 to that in 2002?
Make the answer very short. 0.97. What is the ratio of the GDP(constant 2005 US) in Iran in 1999 to that in 2002?
Ensure brevity in your answer.  0.89. What is the ratio of the GDP(constant 2005 US) in Luxembourg in 1999 to that in 2002?
Your answer should be very brief. 0.9. What is the ratio of the GDP(constant 2005 US) in Grenada in 1999 to that in 2003?
Offer a very short reply. 0.89. What is the ratio of the GDP(constant 2005 US) of Iran in 1999 to that in 2003?
Ensure brevity in your answer.  0.83. What is the ratio of the GDP(constant 2005 US) in Luxembourg in 1999 to that in 2003?
Your answer should be very brief. 0.9. What is the ratio of the GDP(constant 2005 US) in Grenada in 1999 to that in 2004?
Your response must be concise. 0.9. What is the ratio of the GDP(constant 2005 US) of Iran in 1999 to that in 2004?
Your response must be concise. 0.81. What is the ratio of the GDP(constant 2005 US) in Luxembourg in 1999 to that in 2004?
Your answer should be very brief. 0.88. What is the ratio of the GDP(constant 2005 US) of Grenada in 1999 to that in 2005?
Give a very brief answer. 0.8. What is the ratio of the GDP(constant 2005 US) in Iran in 1999 to that in 2005?
Ensure brevity in your answer.  0.78. What is the ratio of the GDP(constant 2005 US) in Luxembourg in 1999 to that in 2005?
Your response must be concise. 0.86. What is the ratio of the GDP(constant 2005 US) in Iran in 2000 to that in 2001?
Provide a succinct answer. 0.99. What is the ratio of the GDP(constant 2005 US) of Luxembourg in 2000 to that in 2001?
Provide a short and direct response. 0.99. What is the ratio of the GDP(constant 2005 US) in Iran in 2000 to that in 2002?
Offer a very short reply. 0.93. What is the ratio of the GDP(constant 2005 US) of Luxembourg in 2000 to that in 2002?
Give a very brief answer. 0.97. What is the ratio of the GDP(constant 2005 US) of Grenada in 2000 to that in 2003?
Offer a very short reply. 0.91. What is the ratio of the GDP(constant 2005 US) in Iran in 2000 to that in 2003?
Ensure brevity in your answer.  0.87. What is the ratio of the GDP(constant 2005 US) of Luxembourg in 2000 to that in 2003?
Your response must be concise. 0.96. What is the ratio of the GDP(constant 2005 US) of Grenada in 2000 to that in 2004?
Make the answer very short. 0.92. What is the ratio of the GDP(constant 2005 US) in Iran in 2000 to that in 2004?
Keep it short and to the point. 0.84. What is the ratio of the GDP(constant 2005 US) of Luxembourg in 2000 to that in 2004?
Your answer should be very brief. 0.94. What is the ratio of the GDP(constant 2005 US) in Grenada in 2000 to that in 2005?
Keep it short and to the point. 0.81. What is the ratio of the GDP(constant 2005 US) of Iran in 2000 to that in 2005?
Provide a short and direct response. 0.81. What is the ratio of the GDP(constant 2005 US) of Luxembourg in 2000 to that in 2005?
Give a very brief answer. 0.92. What is the ratio of the GDP(constant 2005 US) of Grenada in 2001 to that in 2002?
Offer a terse response. 0.97. What is the ratio of the GDP(constant 2005 US) in Iran in 2001 to that in 2002?
Ensure brevity in your answer.  0.94. What is the ratio of the GDP(constant 2005 US) in Luxembourg in 2001 to that in 2002?
Provide a short and direct response. 0.98. What is the ratio of the GDP(constant 2005 US) of Grenada in 2001 to that in 2003?
Offer a very short reply. 0.89. What is the ratio of the GDP(constant 2005 US) of Iran in 2001 to that in 2003?
Provide a succinct answer. 0.87. What is the ratio of the GDP(constant 2005 US) in Luxembourg in 2001 to that in 2003?
Provide a short and direct response. 0.97. What is the ratio of the GDP(constant 2005 US) of Grenada in 2001 to that in 2004?
Provide a short and direct response. 0.9. What is the ratio of the GDP(constant 2005 US) of Iran in 2001 to that in 2004?
Keep it short and to the point. 0.85. What is the ratio of the GDP(constant 2005 US) in Luxembourg in 2001 to that in 2004?
Give a very brief answer. 0.95. What is the ratio of the GDP(constant 2005 US) of Grenada in 2001 to that in 2005?
Keep it short and to the point. 0.79. What is the ratio of the GDP(constant 2005 US) in Iran in 2001 to that in 2005?
Your response must be concise. 0.82. What is the ratio of the GDP(constant 2005 US) of Luxembourg in 2001 to that in 2005?
Your answer should be very brief. 0.93. What is the ratio of the GDP(constant 2005 US) in Grenada in 2002 to that in 2003?
Offer a terse response. 0.92. What is the ratio of the GDP(constant 2005 US) of Iran in 2002 to that in 2003?
Provide a short and direct response. 0.93. What is the ratio of the GDP(constant 2005 US) in Luxembourg in 2002 to that in 2003?
Provide a short and direct response. 1. What is the ratio of the GDP(constant 2005 US) of Grenada in 2002 to that in 2004?
Keep it short and to the point. 0.92. What is the ratio of the GDP(constant 2005 US) of Iran in 2002 to that in 2004?
Your response must be concise. 0.9. What is the ratio of the GDP(constant 2005 US) of Luxembourg in 2002 to that in 2004?
Give a very brief answer. 0.97. What is the ratio of the GDP(constant 2005 US) in Grenada in 2002 to that in 2005?
Your answer should be compact. 0.82. What is the ratio of the GDP(constant 2005 US) of Iran in 2002 to that in 2005?
Keep it short and to the point. 0.88. What is the ratio of the GDP(constant 2005 US) of Luxembourg in 2002 to that in 2005?
Provide a succinct answer. 0.95. What is the ratio of the GDP(constant 2005 US) in Grenada in 2003 to that in 2004?
Your response must be concise. 1.01. What is the ratio of the GDP(constant 2005 US) of Iran in 2003 to that in 2004?
Offer a terse response. 0.97. What is the ratio of the GDP(constant 2005 US) in Luxembourg in 2003 to that in 2004?
Provide a short and direct response. 0.97. What is the ratio of the GDP(constant 2005 US) in Grenada in 2003 to that in 2005?
Offer a terse response. 0.89. What is the ratio of the GDP(constant 2005 US) of Luxembourg in 2003 to that in 2005?
Your response must be concise. 0.96. What is the ratio of the GDP(constant 2005 US) in Grenada in 2004 to that in 2005?
Provide a succinct answer. 0.89. What is the ratio of the GDP(constant 2005 US) of Iran in 2004 to that in 2005?
Your response must be concise. 0.97. What is the ratio of the GDP(constant 2005 US) in Luxembourg in 2004 to that in 2005?
Offer a terse response. 0.98. What is the difference between the highest and the second highest GDP(constant 2005 US) in Grenada?
Your answer should be compact. 718.6. What is the difference between the highest and the second highest GDP(constant 2005 US) in Iran?
Your answer should be very brief. 91.89. What is the difference between the highest and the second highest GDP(constant 2005 US) in Luxembourg?
Keep it short and to the point. 1289.74. What is the difference between the highest and the lowest GDP(constant 2005 US) in Grenada?
Give a very brief answer. 1851.11. What is the difference between the highest and the lowest GDP(constant 2005 US) of Iran?
Your answer should be very brief. 686.51. What is the difference between the highest and the lowest GDP(constant 2005 US) in Luxembourg?
Offer a terse response. 1.55e+04. 